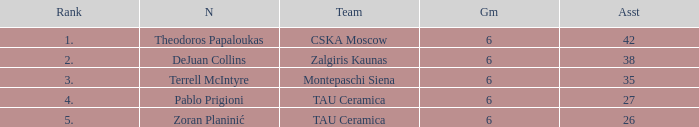What is the least number of assists among players ranked 2? 38.0. 